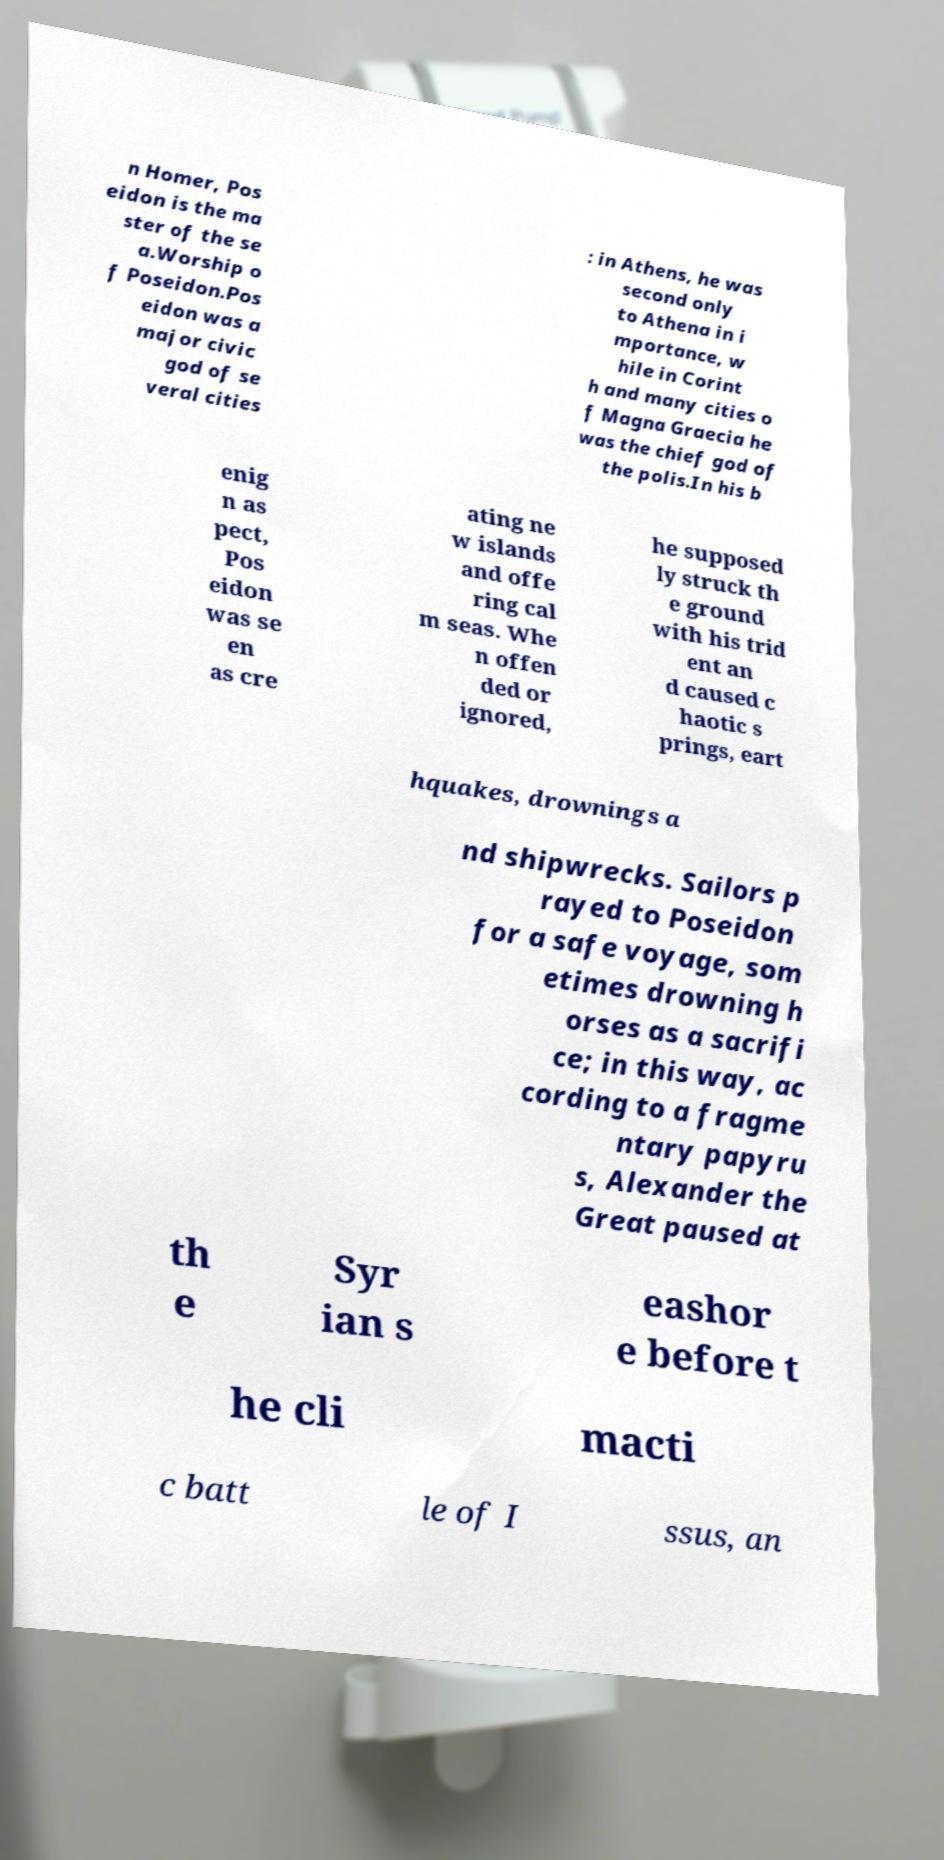Could you assist in decoding the text presented in this image and type it out clearly? n Homer, Pos eidon is the ma ster of the se a.Worship o f Poseidon.Pos eidon was a major civic god of se veral cities : in Athens, he was second only to Athena in i mportance, w hile in Corint h and many cities o f Magna Graecia he was the chief god of the polis.In his b enig n as pect, Pos eidon was se en as cre ating ne w islands and offe ring cal m seas. Whe n offen ded or ignored, he supposed ly struck th e ground with his trid ent an d caused c haotic s prings, eart hquakes, drownings a nd shipwrecks. Sailors p rayed to Poseidon for a safe voyage, som etimes drowning h orses as a sacrifi ce; in this way, ac cording to a fragme ntary papyru s, Alexander the Great paused at th e Syr ian s eashor e before t he cli macti c batt le of I ssus, an 